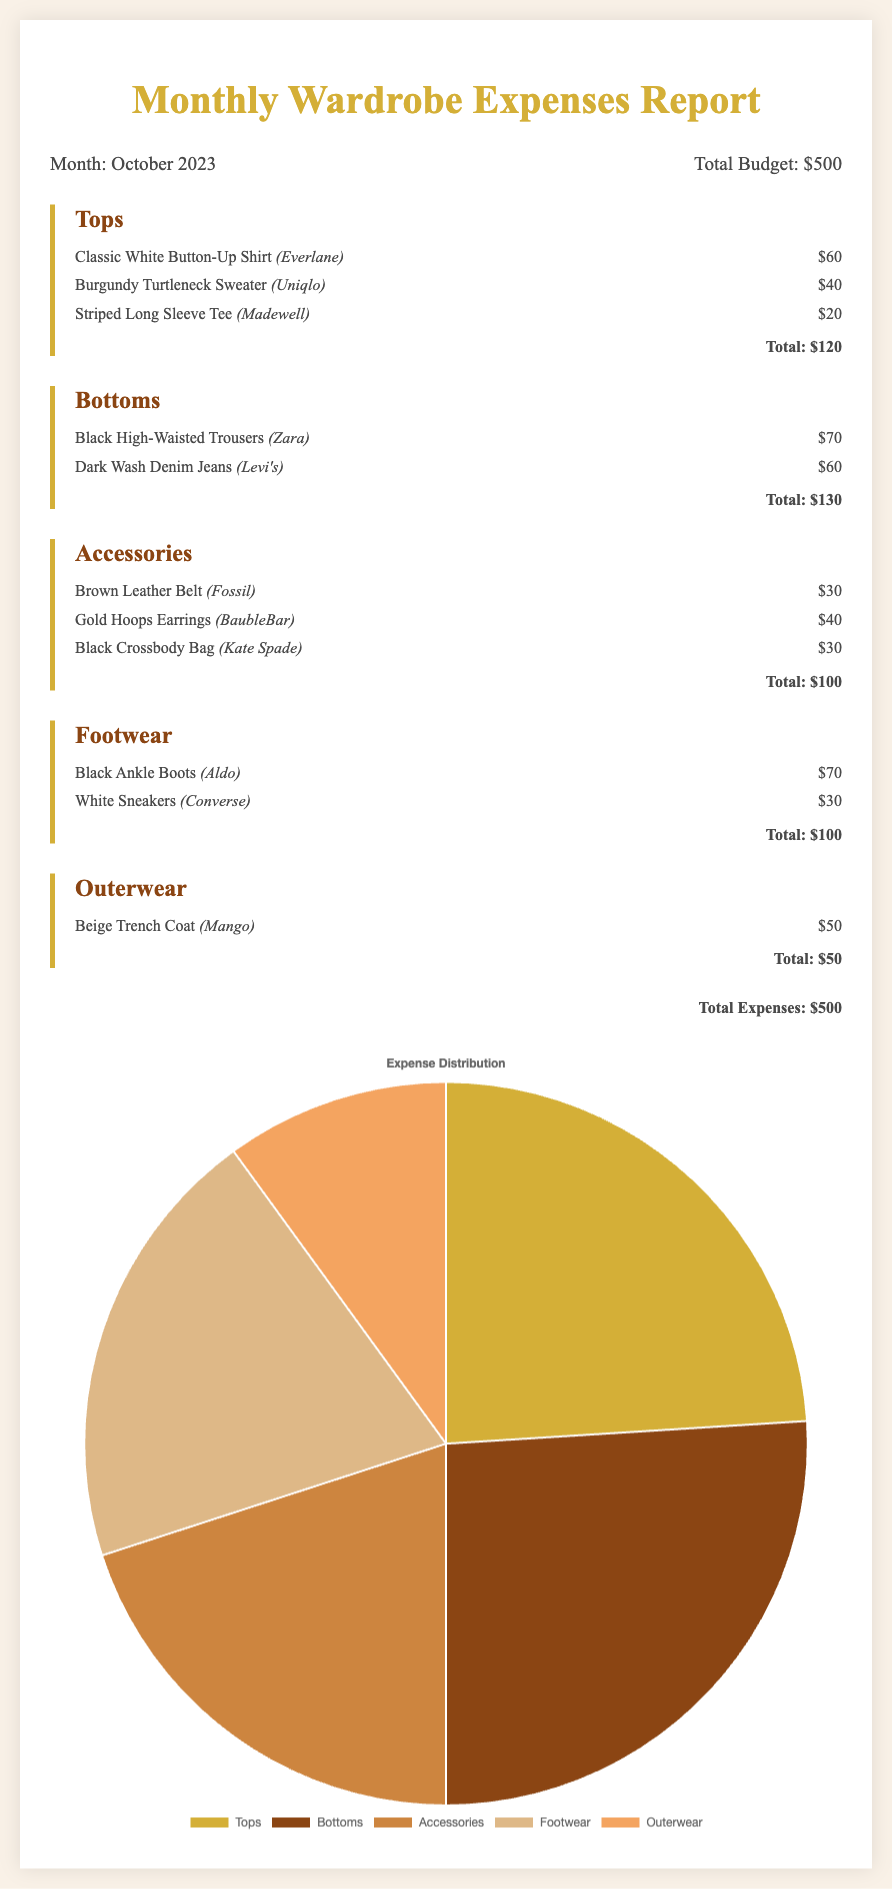What is the total budget for October 2023? The total budget is explicitly stated in the summary section of the document.
Answer: $500 What category has the highest expense? To determine this, we can compare the total expenses listed for each category: Tops ($120), Bottoms ($130), Accessories ($100), Footwear ($100), and Outerwear ($50). The highest is Bottoms.
Answer: Bottoms How much was spent on Accessories? The total for Accessories is clearly listed under that category in the report.
Answer: $100 Which footwear item is the least expensive? By looking at the items listed under Footwear, we can identify that White Sneakers costs $30, which is the lowest price.
Answer: White Sneakers What is the total spent on Tops? The total for Tops is provided at the end of that category section, allowing for a straightforward calculation.
Answer: $120 How many items were purchased in total? The document lists each item under their specific categories, and we can count them to find the total number. There are 10 items in total.
Answer: 10 What percentage of the budget did Outerwear account for? To find this, we can calculate (50/500) * 100, which then gives the percentage of the total budget that was spent on Outerwear.
Answer: 10% Which brand is associated with the Black Crossbody Bag? The document specifies the brand for each accessory item, making it clear that the brand is Kate Spade.
Answer: Kate Spade What is the total spent on Footwear? The expense for Footwear is clearly outlined at the end of the category section in the report.
Answer: $100 